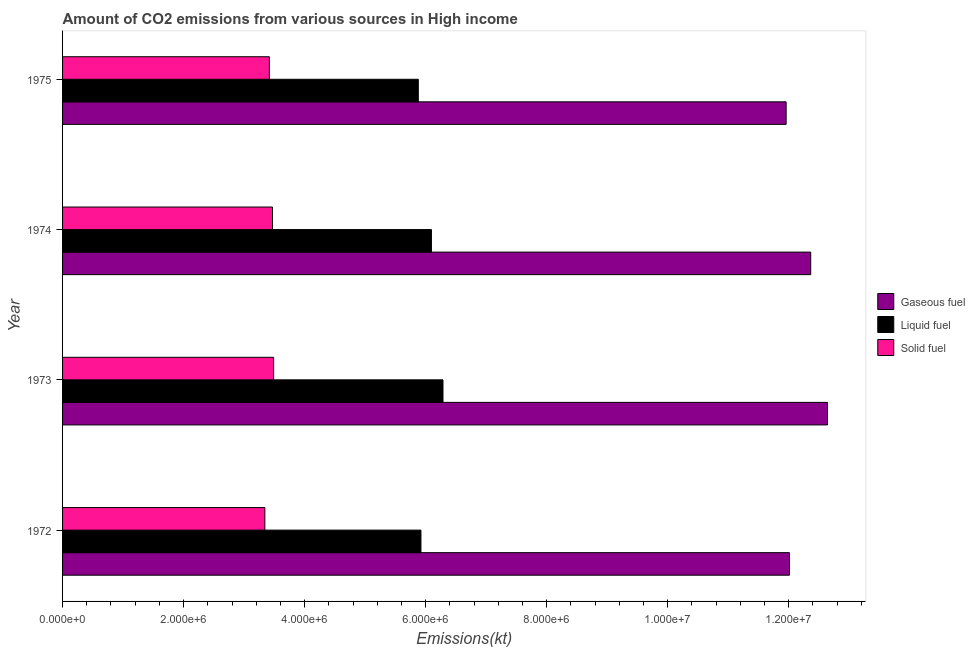How many different coloured bars are there?
Make the answer very short. 3. Are the number of bars on each tick of the Y-axis equal?
Offer a very short reply. Yes. How many bars are there on the 3rd tick from the bottom?
Your answer should be very brief. 3. What is the label of the 1st group of bars from the top?
Offer a terse response. 1975. In how many cases, is the number of bars for a given year not equal to the number of legend labels?
Your answer should be compact. 0. What is the amount of co2 emissions from solid fuel in 1975?
Give a very brief answer. 3.42e+06. Across all years, what is the maximum amount of co2 emissions from liquid fuel?
Provide a succinct answer. 6.29e+06. Across all years, what is the minimum amount of co2 emissions from solid fuel?
Provide a short and direct response. 3.34e+06. In which year was the amount of co2 emissions from gaseous fuel minimum?
Your answer should be very brief. 1975. What is the total amount of co2 emissions from solid fuel in the graph?
Provide a short and direct response. 1.37e+07. What is the difference between the amount of co2 emissions from liquid fuel in 1973 and that in 1974?
Provide a succinct answer. 1.91e+05. What is the difference between the amount of co2 emissions from solid fuel in 1972 and the amount of co2 emissions from gaseous fuel in 1973?
Offer a very short reply. -9.30e+06. What is the average amount of co2 emissions from liquid fuel per year?
Provide a succinct answer. 6.05e+06. In the year 1973, what is the difference between the amount of co2 emissions from liquid fuel and amount of co2 emissions from gaseous fuel?
Give a very brief answer. -6.35e+06. In how many years, is the amount of co2 emissions from solid fuel greater than 2400000 kt?
Keep it short and to the point. 4. What is the difference between the highest and the second highest amount of co2 emissions from solid fuel?
Offer a terse response. 1.88e+04. What is the difference between the highest and the lowest amount of co2 emissions from gaseous fuel?
Keep it short and to the point. 6.84e+05. What does the 3rd bar from the top in 1975 represents?
Offer a very short reply. Gaseous fuel. What does the 1st bar from the bottom in 1972 represents?
Provide a succinct answer. Gaseous fuel. How many years are there in the graph?
Offer a terse response. 4. Are the values on the major ticks of X-axis written in scientific E-notation?
Your response must be concise. Yes. Does the graph contain grids?
Give a very brief answer. No. How many legend labels are there?
Your answer should be very brief. 3. How are the legend labels stacked?
Your response must be concise. Vertical. What is the title of the graph?
Provide a succinct answer. Amount of CO2 emissions from various sources in High income. What is the label or title of the X-axis?
Ensure brevity in your answer.  Emissions(kt). What is the Emissions(kt) of Gaseous fuel in 1972?
Offer a very short reply. 1.20e+07. What is the Emissions(kt) in Liquid fuel in 1972?
Your response must be concise. 5.92e+06. What is the Emissions(kt) of Solid fuel in 1972?
Ensure brevity in your answer.  3.34e+06. What is the Emissions(kt) in Gaseous fuel in 1973?
Make the answer very short. 1.26e+07. What is the Emissions(kt) of Liquid fuel in 1973?
Provide a short and direct response. 6.29e+06. What is the Emissions(kt) in Solid fuel in 1973?
Give a very brief answer. 3.49e+06. What is the Emissions(kt) of Gaseous fuel in 1974?
Keep it short and to the point. 1.24e+07. What is the Emissions(kt) in Liquid fuel in 1974?
Your response must be concise. 6.10e+06. What is the Emissions(kt) in Solid fuel in 1974?
Your answer should be compact. 3.47e+06. What is the Emissions(kt) of Gaseous fuel in 1975?
Offer a very short reply. 1.20e+07. What is the Emissions(kt) in Liquid fuel in 1975?
Your answer should be very brief. 5.88e+06. What is the Emissions(kt) of Solid fuel in 1975?
Your answer should be very brief. 3.42e+06. Across all years, what is the maximum Emissions(kt) of Gaseous fuel?
Provide a short and direct response. 1.26e+07. Across all years, what is the maximum Emissions(kt) of Liquid fuel?
Make the answer very short. 6.29e+06. Across all years, what is the maximum Emissions(kt) in Solid fuel?
Offer a very short reply. 3.49e+06. Across all years, what is the minimum Emissions(kt) in Gaseous fuel?
Your answer should be very brief. 1.20e+07. Across all years, what is the minimum Emissions(kt) of Liquid fuel?
Make the answer very short. 5.88e+06. Across all years, what is the minimum Emissions(kt) of Solid fuel?
Give a very brief answer. 3.34e+06. What is the total Emissions(kt) of Gaseous fuel in the graph?
Provide a succinct answer. 4.90e+07. What is the total Emissions(kt) in Liquid fuel in the graph?
Your answer should be compact. 2.42e+07. What is the total Emissions(kt) in Solid fuel in the graph?
Make the answer very short. 1.37e+07. What is the difference between the Emissions(kt) in Gaseous fuel in 1972 and that in 1973?
Provide a short and direct response. -6.28e+05. What is the difference between the Emissions(kt) of Liquid fuel in 1972 and that in 1973?
Offer a very short reply. -3.64e+05. What is the difference between the Emissions(kt) of Solid fuel in 1972 and that in 1973?
Your answer should be very brief. -1.45e+05. What is the difference between the Emissions(kt) in Gaseous fuel in 1972 and that in 1974?
Keep it short and to the point. -3.50e+05. What is the difference between the Emissions(kt) in Liquid fuel in 1972 and that in 1974?
Give a very brief answer. -1.74e+05. What is the difference between the Emissions(kt) of Solid fuel in 1972 and that in 1974?
Give a very brief answer. -1.26e+05. What is the difference between the Emissions(kt) in Gaseous fuel in 1972 and that in 1975?
Offer a very short reply. 5.65e+04. What is the difference between the Emissions(kt) of Liquid fuel in 1972 and that in 1975?
Ensure brevity in your answer.  4.36e+04. What is the difference between the Emissions(kt) in Solid fuel in 1972 and that in 1975?
Offer a terse response. -7.48e+04. What is the difference between the Emissions(kt) of Gaseous fuel in 1973 and that in 1974?
Ensure brevity in your answer.  2.77e+05. What is the difference between the Emissions(kt) in Liquid fuel in 1973 and that in 1974?
Provide a succinct answer. 1.91e+05. What is the difference between the Emissions(kt) in Solid fuel in 1973 and that in 1974?
Your response must be concise. 1.88e+04. What is the difference between the Emissions(kt) of Gaseous fuel in 1973 and that in 1975?
Your answer should be very brief. 6.84e+05. What is the difference between the Emissions(kt) in Liquid fuel in 1973 and that in 1975?
Give a very brief answer. 4.08e+05. What is the difference between the Emissions(kt) of Solid fuel in 1973 and that in 1975?
Give a very brief answer. 7.00e+04. What is the difference between the Emissions(kt) of Gaseous fuel in 1974 and that in 1975?
Offer a very short reply. 4.07e+05. What is the difference between the Emissions(kt) of Liquid fuel in 1974 and that in 1975?
Offer a terse response. 2.17e+05. What is the difference between the Emissions(kt) of Solid fuel in 1974 and that in 1975?
Offer a very short reply. 5.12e+04. What is the difference between the Emissions(kt) in Gaseous fuel in 1972 and the Emissions(kt) in Liquid fuel in 1973?
Your response must be concise. 5.73e+06. What is the difference between the Emissions(kt) of Gaseous fuel in 1972 and the Emissions(kt) of Solid fuel in 1973?
Give a very brief answer. 8.53e+06. What is the difference between the Emissions(kt) in Liquid fuel in 1972 and the Emissions(kt) in Solid fuel in 1973?
Give a very brief answer. 2.43e+06. What is the difference between the Emissions(kt) of Gaseous fuel in 1972 and the Emissions(kt) of Liquid fuel in 1974?
Offer a very short reply. 5.92e+06. What is the difference between the Emissions(kt) of Gaseous fuel in 1972 and the Emissions(kt) of Solid fuel in 1974?
Your answer should be compact. 8.54e+06. What is the difference between the Emissions(kt) in Liquid fuel in 1972 and the Emissions(kt) in Solid fuel in 1974?
Keep it short and to the point. 2.45e+06. What is the difference between the Emissions(kt) of Gaseous fuel in 1972 and the Emissions(kt) of Liquid fuel in 1975?
Your answer should be very brief. 6.14e+06. What is the difference between the Emissions(kt) of Gaseous fuel in 1972 and the Emissions(kt) of Solid fuel in 1975?
Your answer should be compact. 8.60e+06. What is the difference between the Emissions(kt) of Liquid fuel in 1972 and the Emissions(kt) of Solid fuel in 1975?
Your response must be concise. 2.50e+06. What is the difference between the Emissions(kt) in Gaseous fuel in 1973 and the Emissions(kt) in Liquid fuel in 1974?
Make the answer very short. 6.55e+06. What is the difference between the Emissions(kt) of Gaseous fuel in 1973 and the Emissions(kt) of Solid fuel in 1974?
Give a very brief answer. 9.17e+06. What is the difference between the Emissions(kt) of Liquid fuel in 1973 and the Emissions(kt) of Solid fuel in 1974?
Ensure brevity in your answer.  2.82e+06. What is the difference between the Emissions(kt) in Gaseous fuel in 1973 and the Emissions(kt) in Liquid fuel in 1975?
Make the answer very short. 6.76e+06. What is the difference between the Emissions(kt) in Gaseous fuel in 1973 and the Emissions(kt) in Solid fuel in 1975?
Offer a very short reply. 9.22e+06. What is the difference between the Emissions(kt) of Liquid fuel in 1973 and the Emissions(kt) of Solid fuel in 1975?
Give a very brief answer. 2.87e+06. What is the difference between the Emissions(kt) in Gaseous fuel in 1974 and the Emissions(kt) in Liquid fuel in 1975?
Make the answer very short. 6.49e+06. What is the difference between the Emissions(kt) in Gaseous fuel in 1974 and the Emissions(kt) in Solid fuel in 1975?
Your answer should be compact. 8.95e+06. What is the difference between the Emissions(kt) of Liquid fuel in 1974 and the Emissions(kt) of Solid fuel in 1975?
Your response must be concise. 2.68e+06. What is the average Emissions(kt) in Gaseous fuel per year?
Ensure brevity in your answer.  1.22e+07. What is the average Emissions(kt) in Liquid fuel per year?
Keep it short and to the point. 6.05e+06. What is the average Emissions(kt) in Solid fuel per year?
Make the answer very short. 3.43e+06. In the year 1972, what is the difference between the Emissions(kt) of Gaseous fuel and Emissions(kt) of Liquid fuel?
Offer a terse response. 6.09e+06. In the year 1972, what is the difference between the Emissions(kt) in Gaseous fuel and Emissions(kt) in Solid fuel?
Offer a very short reply. 8.67e+06. In the year 1972, what is the difference between the Emissions(kt) in Liquid fuel and Emissions(kt) in Solid fuel?
Keep it short and to the point. 2.58e+06. In the year 1973, what is the difference between the Emissions(kt) in Gaseous fuel and Emissions(kt) in Liquid fuel?
Offer a terse response. 6.35e+06. In the year 1973, what is the difference between the Emissions(kt) of Gaseous fuel and Emissions(kt) of Solid fuel?
Provide a short and direct response. 9.15e+06. In the year 1973, what is the difference between the Emissions(kt) of Liquid fuel and Emissions(kt) of Solid fuel?
Ensure brevity in your answer.  2.80e+06. In the year 1974, what is the difference between the Emissions(kt) in Gaseous fuel and Emissions(kt) in Liquid fuel?
Offer a terse response. 6.27e+06. In the year 1974, what is the difference between the Emissions(kt) in Gaseous fuel and Emissions(kt) in Solid fuel?
Offer a terse response. 8.90e+06. In the year 1974, what is the difference between the Emissions(kt) of Liquid fuel and Emissions(kt) of Solid fuel?
Offer a terse response. 2.63e+06. In the year 1975, what is the difference between the Emissions(kt) in Gaseous fuel and Emissions(kt) in Liquid fuel?
Your answer should be very brief. 6.08e+06. In the year 1975, what is the difference between the Emissions(kt) of Gaseous fuel and Emissions(kt) of Solid fuel?
Your response must be concise. 8.54e+06. In the year 1975, what is the difference between the Emissions(kt) in Liquid fuel and Emissions(kt) in Solid fuel?
Ensure brevity in your answer.  2.46e+06. What is the ratio of the Emissions(kt) of Gaseous fuel in 1972 to that in 1973?
Keep it short and to the point. 0.95. What is the ratio of the Emissions(kt) of Liquid fuel in 1972 to that in 1973?
Offer a terse response. 0.94. What is the ratio of the Emissions(kt) of Solid fuel in 1972 to that in 1973?
Keep it short and to the point. 0.96. What is the ratio of the Emissions(kt) in Gaseous fuel in 1972 to that in 1974?
Give a very brief answer. 0.97. What is the ratio of the Emissions(kt) of Liquid fuel in 1972 to that in 1974?
Provide a short and direct response. 0.97. What is the ratio of the Emissions(kt) in Solid fuel in 1972 to that in 1974?
Ensure brevity in your answer.  0.96. What is the ratio of the Emissions(kt) of Gaseous fuel in 1972 to that in 1975?
Ensure brevity in your answer.  1. What is the ratio of the Emissions(kt) of Liquid fuel in 1972 to that in 1975?
Ensure brevity in your answer.  1.01. What is the ratio of the Emissions(kt) in Solid fuel in 1972 to that in 1975?
Your response must be concise. 0.98. What is the ratio of the Emissions(kt) of Gaseous fuel in 1973 to that in 1974?
Ensure brevity in your answer.  1.02. What is the ratio of the Emissions(kt) in Liquid fuel in 1973 to that in 1974?
Offer a terse response. 1.03. What is the ratio of the Emissions(kt) in Solid fuel in 1973 to that in 1974?
Offer a very short reply. 1.01. What is the ratio of the Emissions(kt) of Gaseous fuel in 1973 to that in 1975?
Provide a short and direct response. 1.06. What is the ratio of the Emissions(kt) of Liquid fuel in 1973 to that in 1975?
Make the answer very short. 1.07. What is the ratio of the Emissions(kt) of Solid fuel in 1973 to that in 1975?
Your response must be concise. 1.02. What is the ratio of the Emissions(kt) in Gaseous fuel in 1974 to that in 1975?
Ensure brevity in your answer.  1.03. What is the ratio of the Emissions(kt) in Liquid fuel in 1974 to that in 1975?
Offer a very short reply. 1.04. What is the ratio of the Emissions(kt) of Solid fuel in 1974 to that in 1975?
Your answer should be very brief. 1.01. What is the difference between the highest and the second highest Emissions(kt) in Gaseous fuel?
Offer a very short reply. 2.77e+05. What is the difference between the highest and the second highest Emissions(kt) in Liquid fuel?
Offer a very short reply. 1.91e+05. What is the difference between the highest and the second highest Emissions(kt) of Solid fuel?
Make the answer very short. 1.88e+04. What is the difference between the highest and the lowest Emissions(kt) in Gaseous fuel?
Make the answer very short. 6.84e+05. What is the difference between the highest and the lowest Emissions(kt) of Liquid fuel?
Offer a very short reply. 4.08e+05. What is the difference between the highest and the lowest Emissions(kt) of Solid fuel?
Provide a succinct answer. 1.45e+05. 